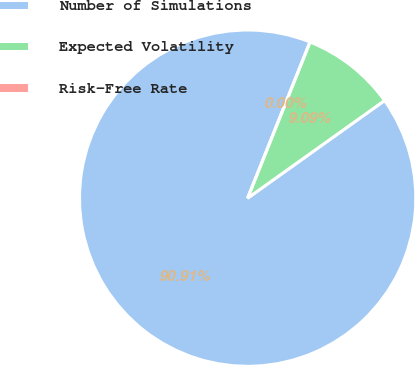Convert chart to OTSL. <chart><loc_0><loc_0><loc_500><loc_500><pie_chart><fcel>Number of Simulations<fcel>Expected Volatility<fcel>Risk-Free Rate<nl><fcel>90.91%<fcel>9.09%<fcel>0.0%<nl></chart> 